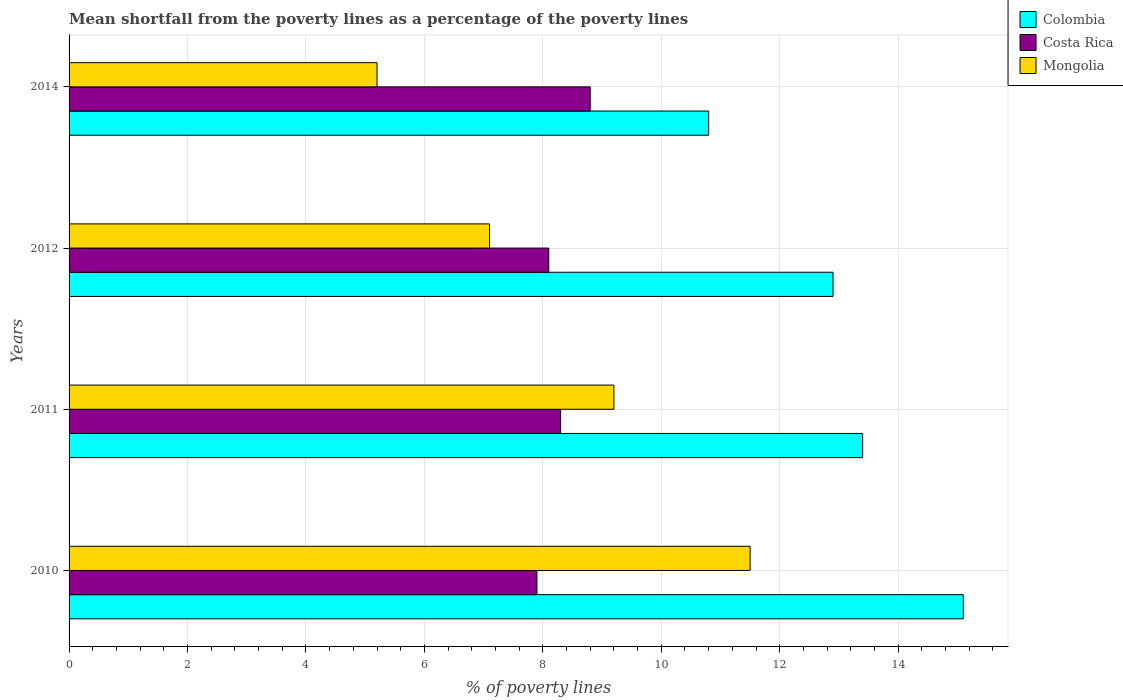How many different coloured bars are there?
Provide a short and direct response. 3. In which year was the mean shortfall from the poverty lines as a percentage of the poverty lines in Colombia maximum?
Provide a short and direct response. 2010. What is the total mean shortfall from the poverty lines as a percentage of the poverty lines in Colombia in the graph?
Provide a succinct answer. 52.2. What is the difference between the mean shortfall from the poverty lines as a percentage of the poverty lines in Costa Rica in 2011 and that in 2012?
Your answer should be very brief. 0.2. What is the difference between the mean shortfall from the poverty lines as a percentage of the poverty lines in Mongolia in 2010 and the mean shortfall from the poverty lines as a percentage of the poverty lines in Colombia in 2014?
Make the answer very short. 0.7. What is the average mean shortfall from the poverty lines as a percentage of the poverty lines in Colombia per year?
Ensure brevity in your answer.  13.05. In the year 2014, what is the difference between the mean shortfall from the poverty lines as a percentage of the poverty lines in Colombia and mean shortfall from the poverty lines as a percentage of the poverty lines in Mongolia?
Offer a terse response. 5.6. What is the ratio of the mean shortfall from the poverty lines as a percentage of the poverty lines in Mongolia in 2011 to that in 2014?
Give a very brief answer. 1.77. What is the difference between the highest and the second highest mean shortfall from the poverty lines as a percentage of the poverty lines in Costa Rica?
Ensure brevity in your answer.  0.5. What is the difference between the highest and the lowest mean shortfall from the poverty lines as a percentage of the poverty lines in Costa Rica?
Provide a succinct answer. 0.9. Is the sum of the mean shortfall from the poverty lines as a percentage of the poverty lines in Mongolia in 2011 and 2014 greater than the maximum mean shortfall from the poverty lines as a percentage of the poverty lines in Costa Rica across all years?
Provide a short and direct response. Yes. What does the 3rd bar from the top in 2010 represents?
Provide a succinct answer. Colombia. What does the 2nd bar from the bottom in 2012 represents?
Offer a terse response. Costa Rica. Is it the case that in every year, the sum of the mean shortfall from the poverty lines as a percentage of the poverty lines in Costa Rica and mean shortfall from the poverty lines as a percentage of the poverty lines in Colombia is greater than the mean shortfall from the poverty lines as a percentage of the poverty lines in Mongolia?
Keep it short and to the point. Yes. How many bars are there?
Provide a succinct answer. 12. How many years are there in the graph?
Offer a terse response. 4. What is the difference between two consecutive major ticks on the X-axis?
Provide a short and direct response. 2. Are the values on the major ticks of X-axis written in scientific E-notation?
Your answer should be compact. No. Does the graph contain any zero values?
Give a very brief answer. No. Where does the legend appear in the graph?
Offer a terse response. Top right. What is the title of the graph?
Your response must be concise. Mean shortfall from the poverty lines as a percentage of the poverty lines. What is the label or title of the X-axis?
Offer a terse response. % of poverty lines. What is the label or title of the Y-axis?
Your answer should be very brief. Years. What is the % of poverty lines of Costa Rica in 2011?
Provide a short and direct response. 8.3. What is the % of poverty lines in Mongolia in 2011?
Your answer should be compact. 9.2. What is the % of poverty lines in Colombia in 2012?
Offer a very short reply. 12.9. Across all years, what is the maximum % of poverty lines in Mongolia?
Provide a succinct answer. 11.5. Across all years, what is the minimum % of poverty lines in Colombia?
Provide a short and direct response. 10.8. Across all years, what is the minimum % of poverty lines of Mongolia?
Your answer should be compact. 5.2. What is the total % of poverty lines in Colombia in the graph?
Keep it short and to the point. 52.2. What is the total % of poverty lines of Costa Rica in the graph?
Your answer should be compact. 33.1. What is the difference between the % of poverty lines in Mongolia in 2010 and that in 2011?
Provide a succinct answer. 2.3. What is the difference between the % of poverty lines in Costa Rica in 2010 and that in 2012?
Provide a succinct answer. -0.2. What is the difference between the % of poverty lines in Colombia in 2010 and that in 2014?
Keep it short and to the point. 4.3. What is the difference between the % of poverty lines in Mongolia in 2010 and that in 2014?
Ensure brevity in your answer.  6.3. What is the difference between the % of poverty lines of Costa Rica in 2011 and that in 2014?
Provide a short and direct response. -0.5. What is the difference between the % of poverty lines in Mongolia in 2011 and that in 2014?
Keep it short and to the point. 4. What is the difference between the % of poverty lines of Colombia in 2010 and the % of poverty lines of Mongolia in 2011?
Your answer should be very brief. 5.9. What is the difference between the % of poverty lines in Colombia in 2010 and the % of poverty lines in Costa Rica in 2012?
Offer a terse response. 7. What is the difference between the % of poverty lines in Colombia in 2010 and the % of poverty lines in Mongolia in 2014?
Ensure brevity in your answer.  9.9. What is the difference between the % of poverty lines of Colombia in 2011 and the % of poverty lines of Costa Rica in 2012?
Your answer should be compact. 5.3. What is the difference between the % of poverty lines in Colombia in 2011 and the % of poverty lines in Costa Rica in 2014?
Ensure brevity in your answer.  4.6. What is the difference between the % of poverty lines in Colombia in 2011 and the % of poverty lines in Mongolia in 2014?
Give a very brief answer. 8.2. What is the difference between the % of poverty lines of Costa Rica in 2011 and the % of poverty lines of Mongolia in 2014?
Make the answer very short. 3.1. What is the difference between the % of poverty lines of Colombia in 2012 and the % of poverty lines of Costa Rica in 2014?
Keep it short and to the point. 4.1. What is the difference between the % of poverty lines in Colombia in 2012 and the % of poverty lines in Mongolia in 2014?
Your response must be concise. 7.7. What is the average % of poverty lines in Colombia per year?
Keep it short and to the point. 13.05. What is the average % of poverty lines in Costa Rica per year?
Provide a short and direct response. 8.28. What is the average % of poverty lines of Mongolia per year?
Your answer should be compact. 8.25. In the year 2010, what is the difference between the % of poverty lines of Colombia and % of poverty lines of Costa Rica?
Make the answer very short. 7.2. In the year 2011, what is the difference between the % of poverty lines in Colombia and % of poverty lines in Mongolia?
Ensure brevity in your answer.  4.2. In the year 2012, what is the difference between the % of poverty lines in Colombia and % of poverty lines in Costa Rica?
Give a very brief answer. 4.8. In the year 2012, what is the difference between the % of poverty lines of Colombia and % of poverty lines of Mongolia?
Give a very brief answer. 5.8. In the year 2012, what is the difference between the % of poverty lines of Costa Rica and % of poverty lines of Mongolia?
Provide a short and direct response. 1. What is the ratio of the % of poverty lines of Colombia in 2010 to that in 2011?
Provide a succinct answer. 1.13. What is the ratio of the % of poverty lines in Costa Rica in 2010 to that in 2011?
Your response must be concise. 0.95. What is the ratio of the % of poverty lines of Colombia in 2010 to that in 2012?
Your response must be concise. 1.17. What is the ratio of the % of poverty lines in Costa Rica in 2010 to that in 2012?
Your answer should be compact. 0.98. What is the ratio of the % of poverty lines in Mongolia in 2010 to that in 2012?
Ensure brevity in your answer.  1.62. What is the ratio of the % of poverty lines of Colombia in 2010 to that in 2014?
Your response must be concise. 1.4. What is the ratio of the % of poverty lines in Costa Rica in 2010 to that in 2014?
Offer a terse response. 0.9. What is the ratio of the % of poverty lines in Mongolia in 2010 to that in 2014?
Offer a terse response. 2.21. What is the ratio of the % of poverty lines of Colombia in 2011 to that in 2012?
Provide a short and direct response. 1.04. What is the ratio of the % of poverty lines of Costa Rica in 2011 to that in 2012?
Offer a terse response. 1.02. What is the ratio of the % of poverty lines of Mongolia in 2011 to that in 2012?
Provide a succinct answer. 1.3. What is the ratio of the % of poverty lines in Colombia in 2011 to that in 2014?
Ensure brevity in your answer.  1.24. What is the ratio of the % of poverty lines of Costa Rica in 2011 to that in 2014?
Provide a succinct answer. 0.94. What is the ratio of the % of poverty lines of Mongolia in 2011 to that in 2014?
Your answer should be compact. 1.77. What is the ratio of the % of poverty lines in Colombia in 2012 to that in 2014?
Offer a terse response. 1.19. What is the ratio of the % of poverty lines in Costa Rica in 2012 to that in 2014?
Ensure brevity in your answer.  0.92. What is the ratio of the % of poverty lines in Mongolia in 2012 to that in 2014?
Give a very brief answer. 1.37. What is the difference between the highest and the second highest % of poverty lines of Colombia?
Offer a very short reply. 1.7. What is the difference between the highest and the second highest % of poverty lines of Mongolia?
Your response must be concise. 2.3. What is the difference between the highest and the lowest % of poverty lines of Colombia?
Offer a very short reply. 4.3. 